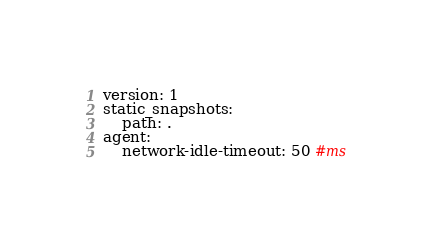Convert code to text. <code><loc_0><loc_0><loc_500><loc_500><_YAML_>version: 1
static_snapshots:
    path: .
agent:
    network-idle-timeout: 50 #ms
</code> 